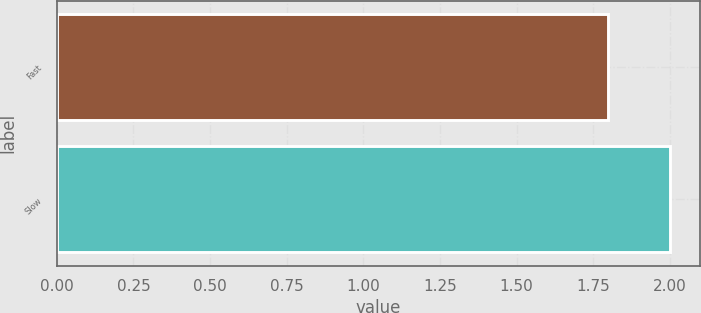Convert chart to OTSL. <chart><loc_0><loc_0><loc_500><loc_500><bar_chart><fcel>Fast<fcel>Slow<nl><fcel>1.8<fcel>2<nl></chart> 